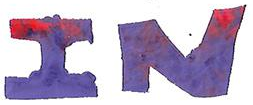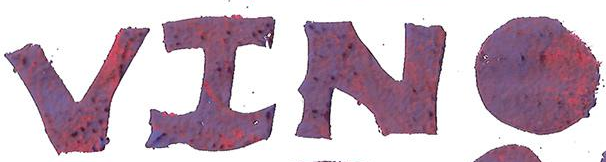Identify the words shown in these images in order, separated by a semicolon. IN; VINO 